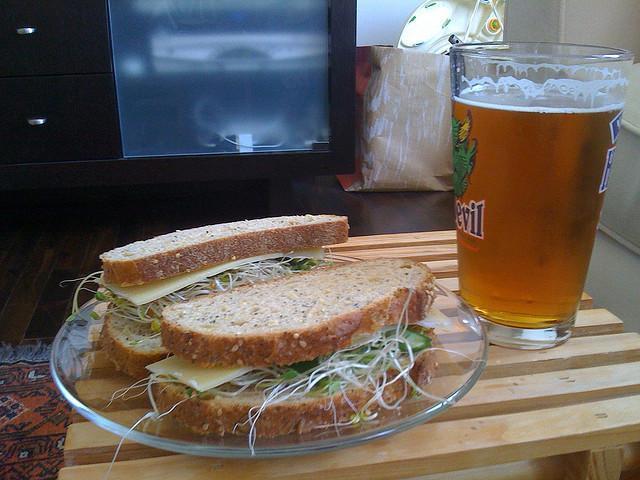How many sandwiches?
Give a very brief answer. 2. How many sandwiches can be seen?
Give a very brief answer. 2. How many people are standing to the left of the open train door?
Give a very brief answer. 0. 